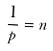<formula> <loc_0><loc_0><loc_500><loc_500>\frac { 1 } { p } = n</formula> 